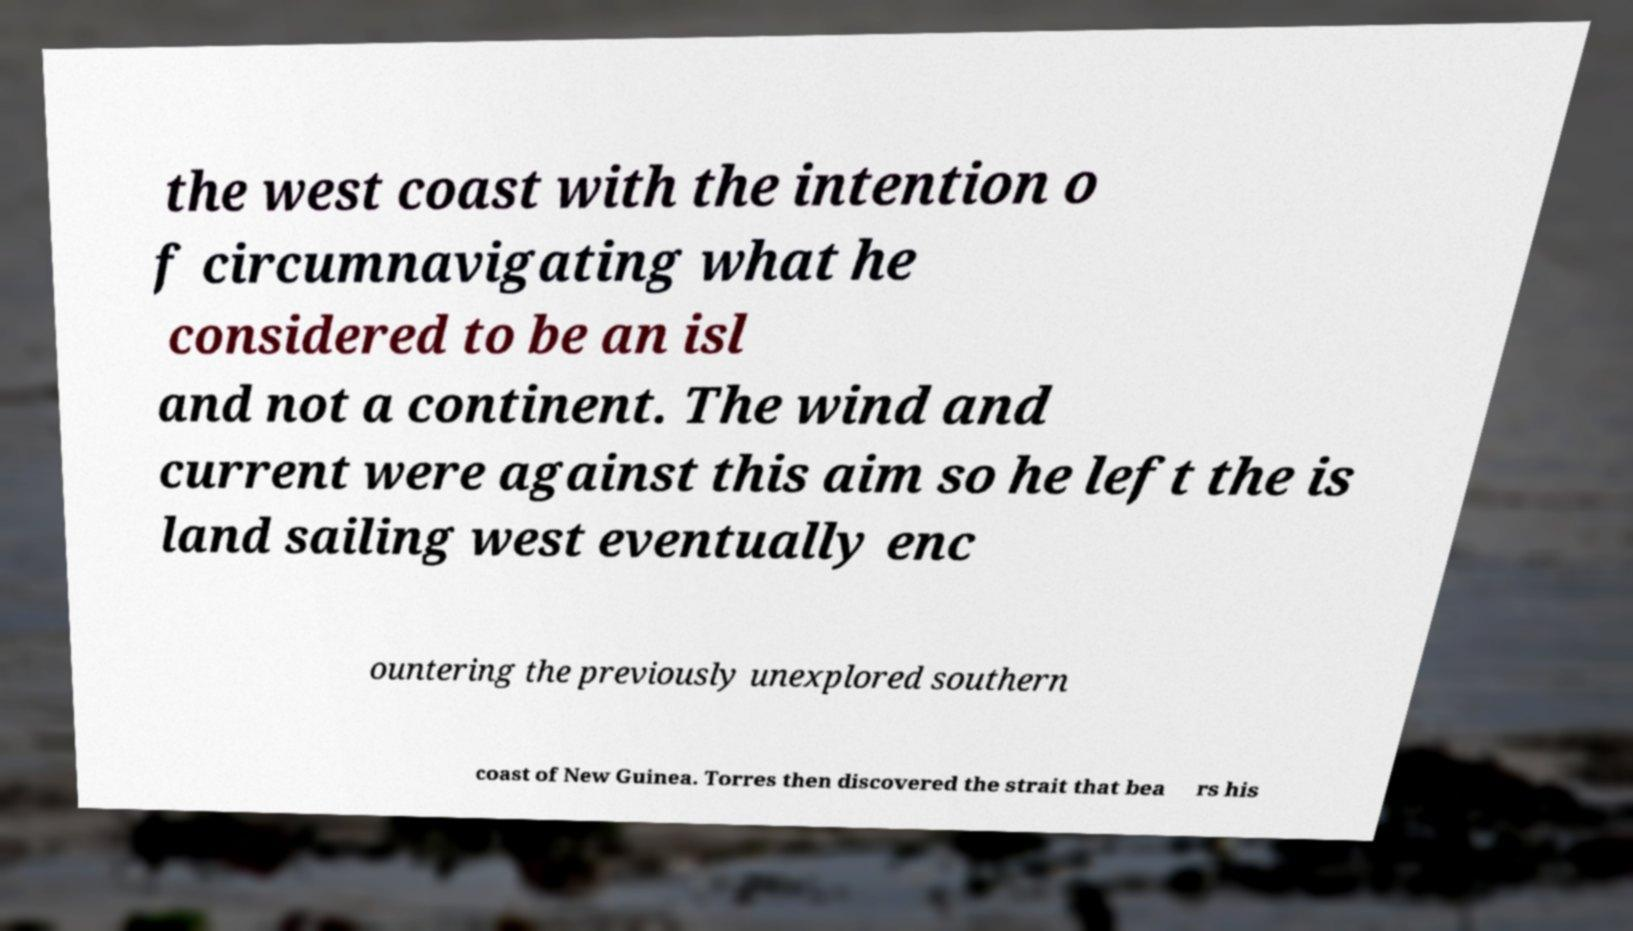Can you accurately transcribe the text from the provided image for me? the west coast with the intention o f circumnavigating what he considered to be an isl and not a continent. The wind and current were against this aim so he left the is land sailing west eventually enc ountering the previously unexplored southern coast of New Guinea. Torres then discovered the strait that bea rs his 